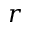Convert formula to latex. <formula><loc_0><loc_0><loc_500><loc_500>r</formula> 